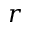Convert formula to latex. <formula><loc_0><loc_0><loc_500><loc_500>r</formula> 